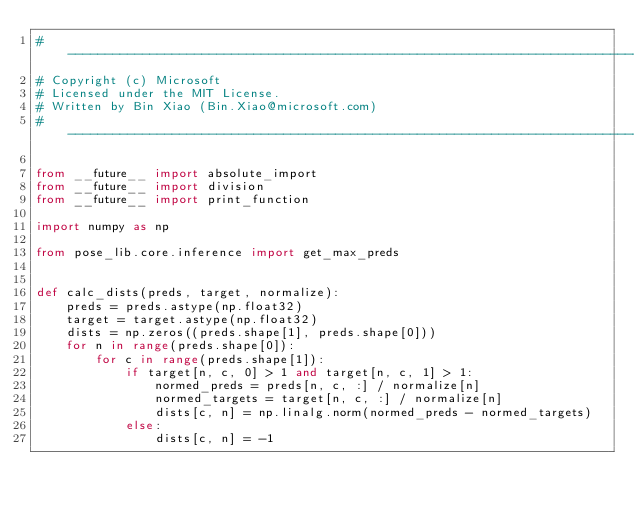<code> <loc_0><loc_0><loc_500><loc_500><_Python_># ------------------------------------------------------------------------------
# Copyright (c) Microsoft
# Licensed under the MIT License.
# Written by Bin Xiao (Bin.Xiao@microsoft.com)
# ------------------------------------------------------------------------------

from __future__ import absolute_import
from __future__ import division
from __future__ import print_function

import numpy as np

from pose_lib.core.inference import get_max_preds


def calc_dists(preds, target, normalize):
    preds = preds.astype(np.float32)
    target = target.astype(np.float32)
    dists = np.zeros((preds.shape[1], preds.shape[0]))
    for n in range(preds.shape[0]):
        for c in range(preds.shape[1]):
            if target[n, c, 0] > 1 and target[n, c, 1] > 1:
                normed_preds = preds[n, c, :] / normalize[n]
                normed_targets = target[n, c, :] / normalize[n]
                dists[c, n] = np.linalg.norm(normed_preds - normed_targets)
            else:
                dists[c, n] = -1</code> 